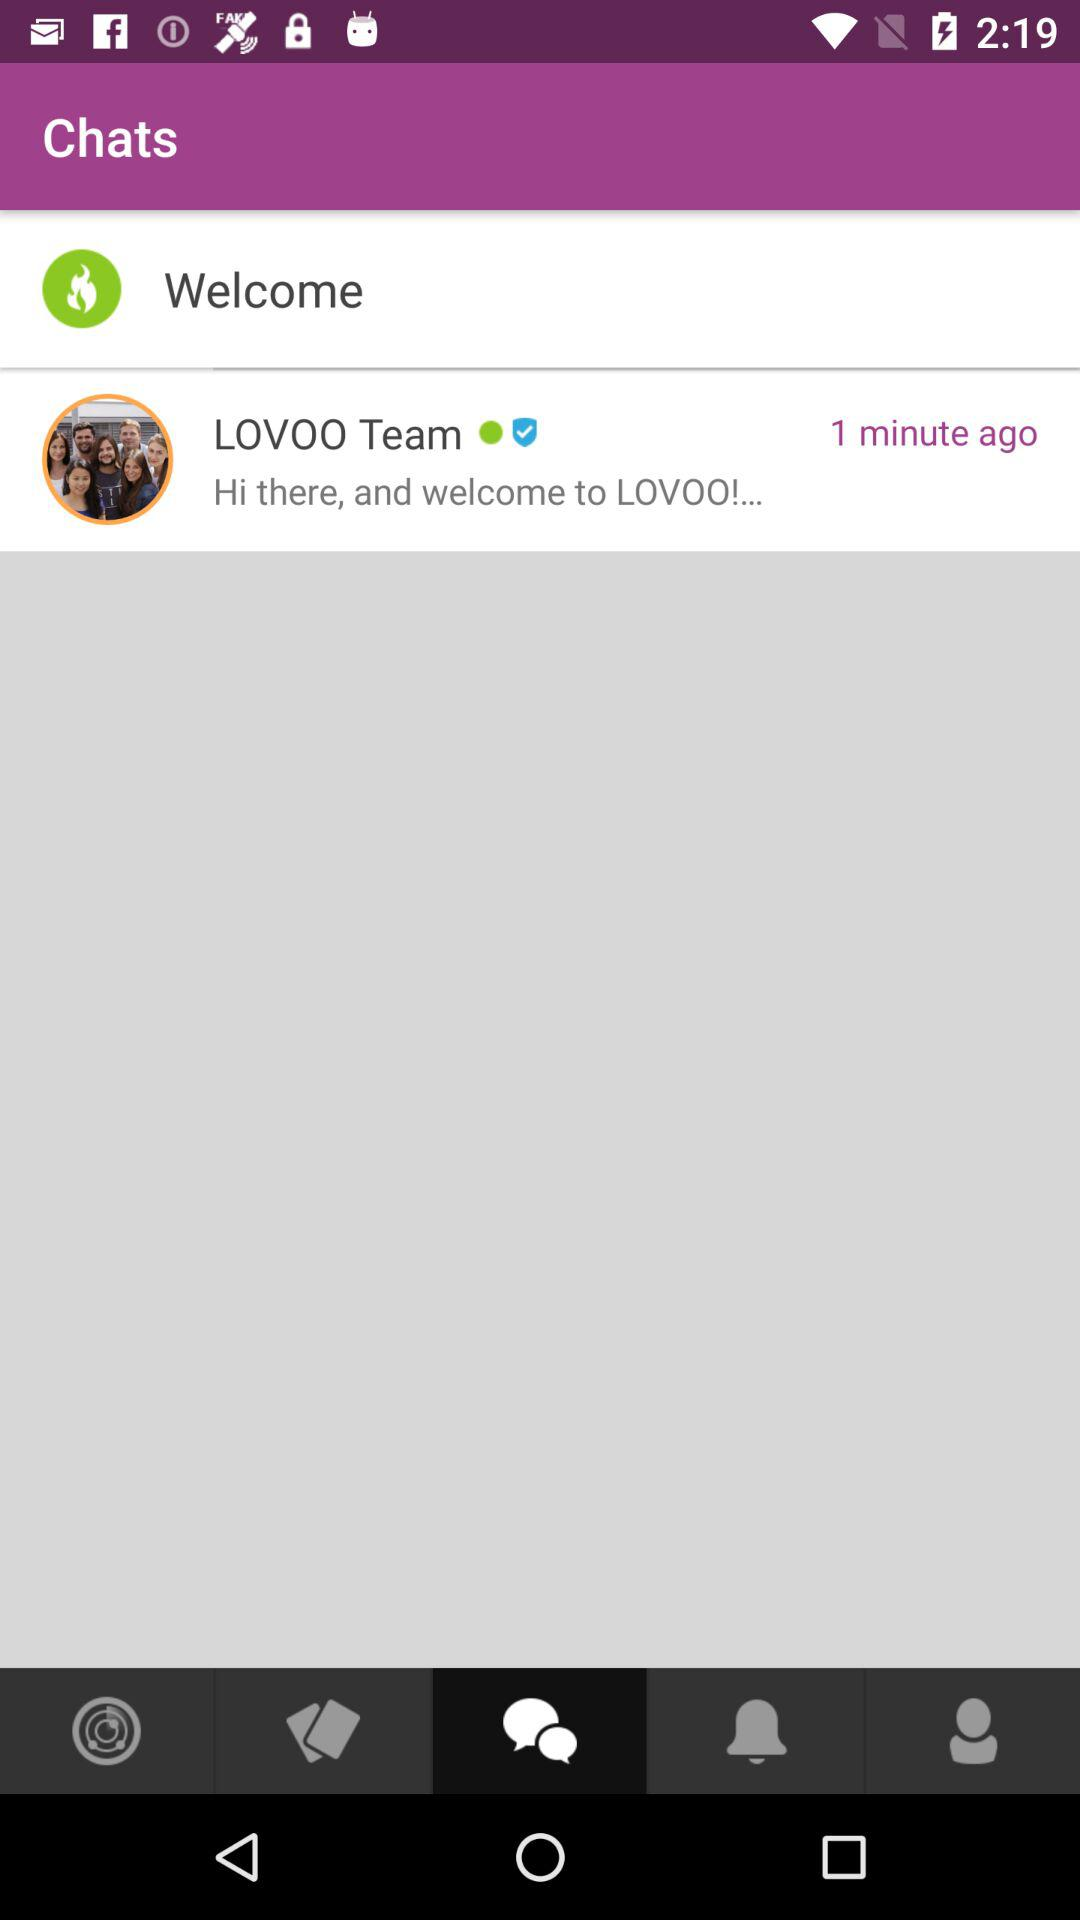When was the LOVOO team available? The LOVOO team was available 1 minute ago. 